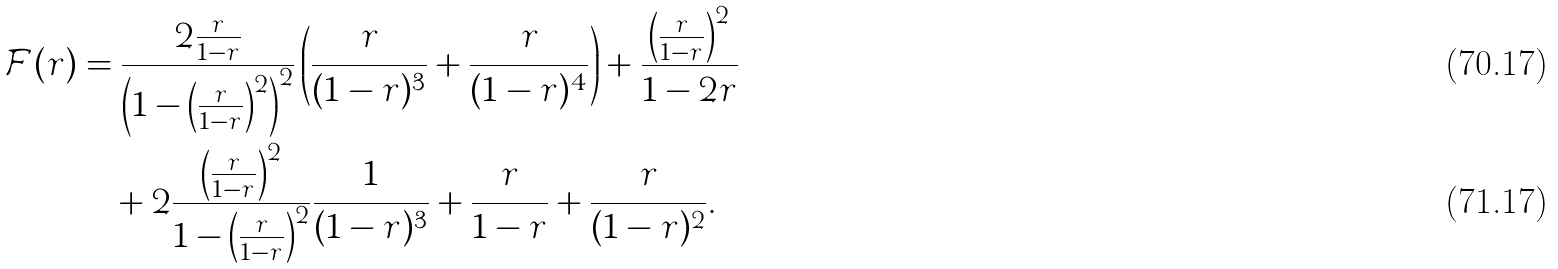Convert formula to latex. <formula><loc_0><loc_0><loc_500><loc_500>\mathcal { F } ( r ) & = \frac { 2 \frac { r } { 1 - r } } { \left ( 1 - \left ( \frac { r } { 1 - r } \right ) ^ { 2 } \right ) ^ { 2 } } \left ( \frac { r } { ( 1 - r ) ^ { 3 } } + \frac { r } { ( 1 - r ) ^ { 4 } } \right ) + \frac { \left ( \frac { r } { 1 - r } \right ) ^ { 2 } } { 1 - 2 r } \\ & \quad + 2 \frac { \left ( \frac { r } { 1 - r } \right ) ^ { 2 } } { 1 - \left ( \frac { r } { 1 - r } \right ) ^ { 2 } } \frac { 1 } { ( 1 - r ) ^ { 3 } } + \frac { r } { 1 - r } + \frac { r } { ( 1 - r ) ^ { 2 } } .</formula> 